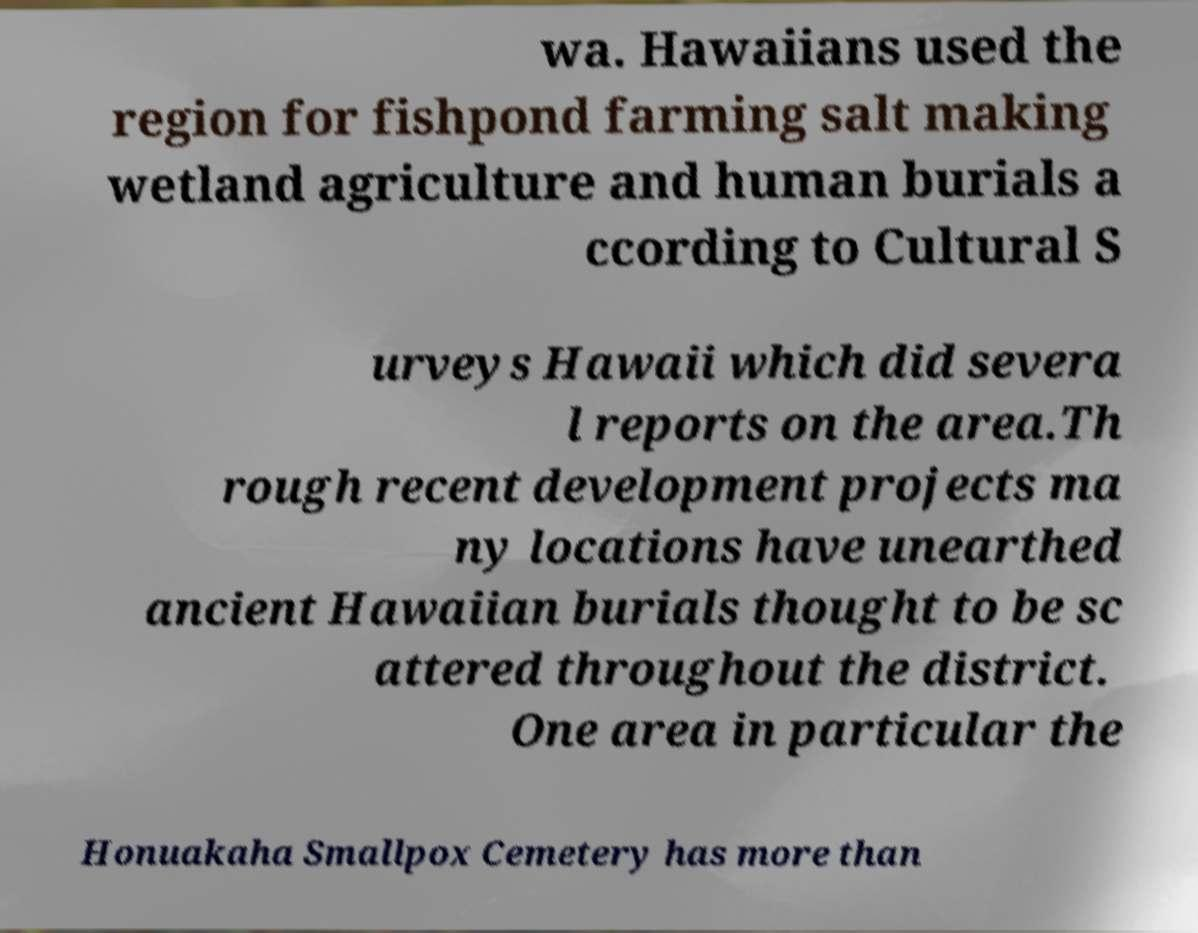Could you assist in decoding the text presented in this image and type it out clearly? wa. Hawaiians used the region for fishpond farming salt making wetland agriculture and human burials a ccording to Cultural S urveys Hawaii which did severa l reports on the area.Th rough recent development projects ma ny locations have unearthed ancient Hawaiian burials thought to be sc attered throughout the district. One area in particular the Honuakaha Smallpox Cemetery has more than 